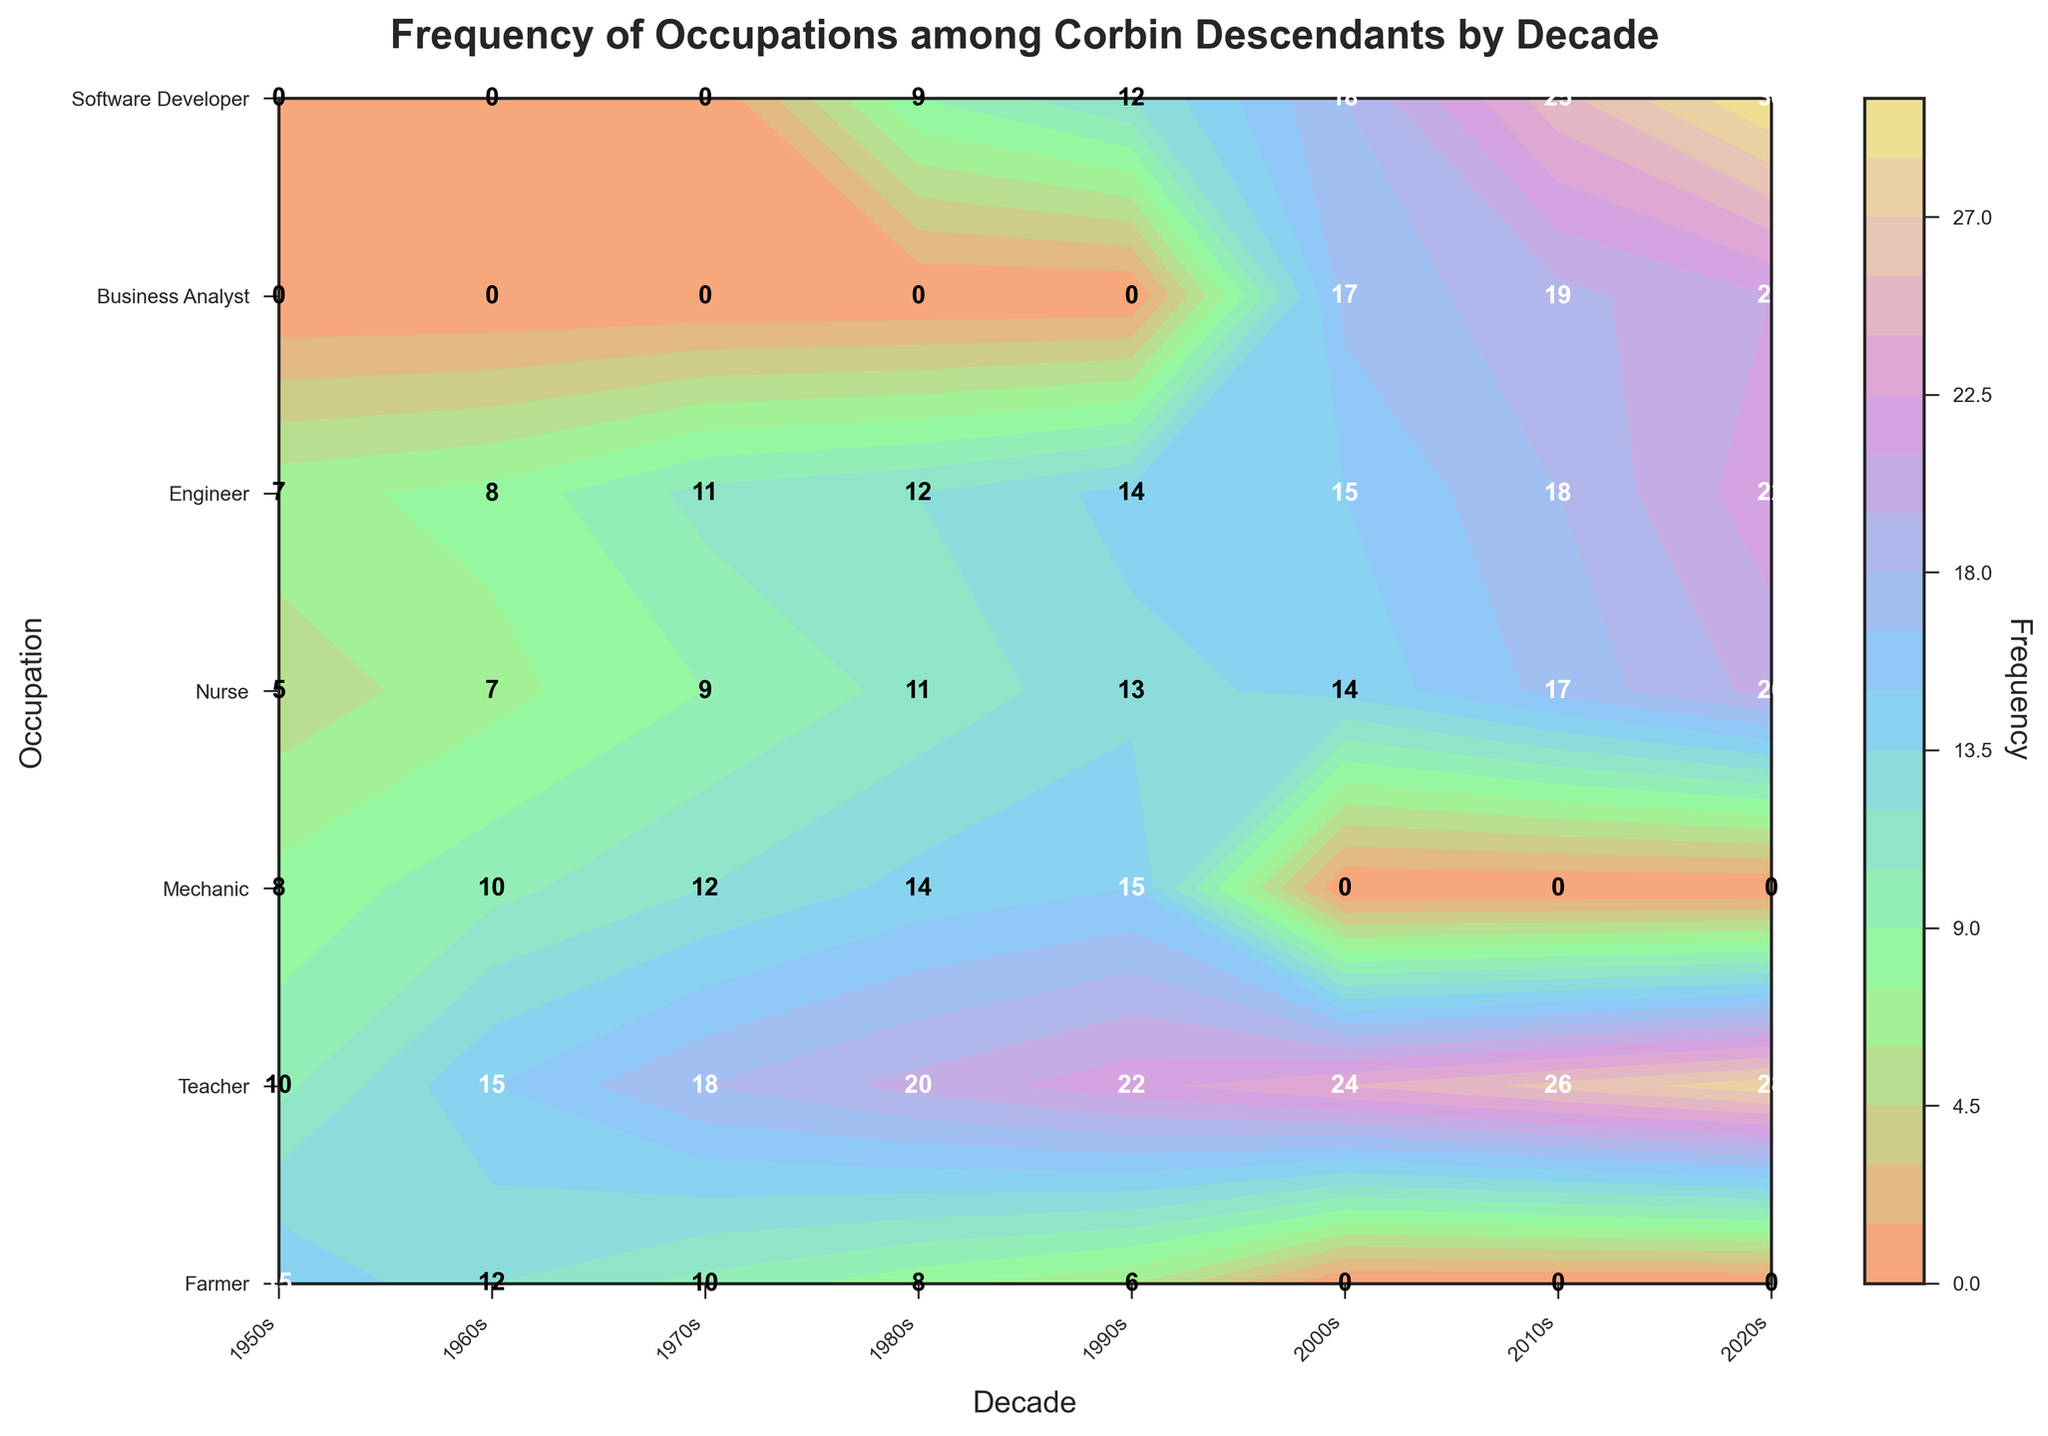What's the title of the plot? The title of the plot is displayed at the top of the figure, centered, and usually in a larger font size. It provides a quick summary of what the plot is about.
Answer: Frequency of Occupations among Corbin Descendants by Decade What is the most frequent occupation in the 2020s? Locate the 2020s along the x-axis, then find the row with the highest labeled frequency number in that column.
Answer: Software Developer Which decade has the lowest frequency of Farmers? Locate the rows labeled 'Farmer' and compare the numbers across all those rows. Identify the lowest number.
Answer: 1990s By how much did the frequency of Teachers change from the 1950s to the 2020s? Find the frequency of Teachers in both the 1950s and 2020s. Subtract the 1950s frequency from the 2020s frequency to get the difference.
Answer: 18 How many different occupations can be found in the figure? Count the unique occupation labels displayed along the y-axis.
Answer: 7 Compare the frequency of Nurses and Engineers in the 2010s. Which one is higher? Locate the 2010s along the x-axis. Compare the frequency numbers for Nurses and Engineers in that column.
Answer: Engineer What's the average frequency of Software Developers across all decades? Sum the frequencies of Software Developers for each decade and divide by the number of decades listed for Software Developer.
Answer: 17 Between Business Analyst and Software Developer, which occupation shows a consistent increase in frequency across decades? Examine the frequencies for Business Analyst and Software Developer from their first appearance to the 2020s to determine which one consistently increases.
Answer: Software Developer Which decade has the highest overall frequency for all occupations combined? For each decade, sum the frequencies of all occupations. Identify the decade with the highest total.
Answer: 2020s Are there any occupations that appear only after the 2000s? If yes, which ones? Identify occupations that first appear in the 2000s or later by looking at the y-axis labels and checking their corresponding decade columns.
Answer: Business Analyst, Software Developer 